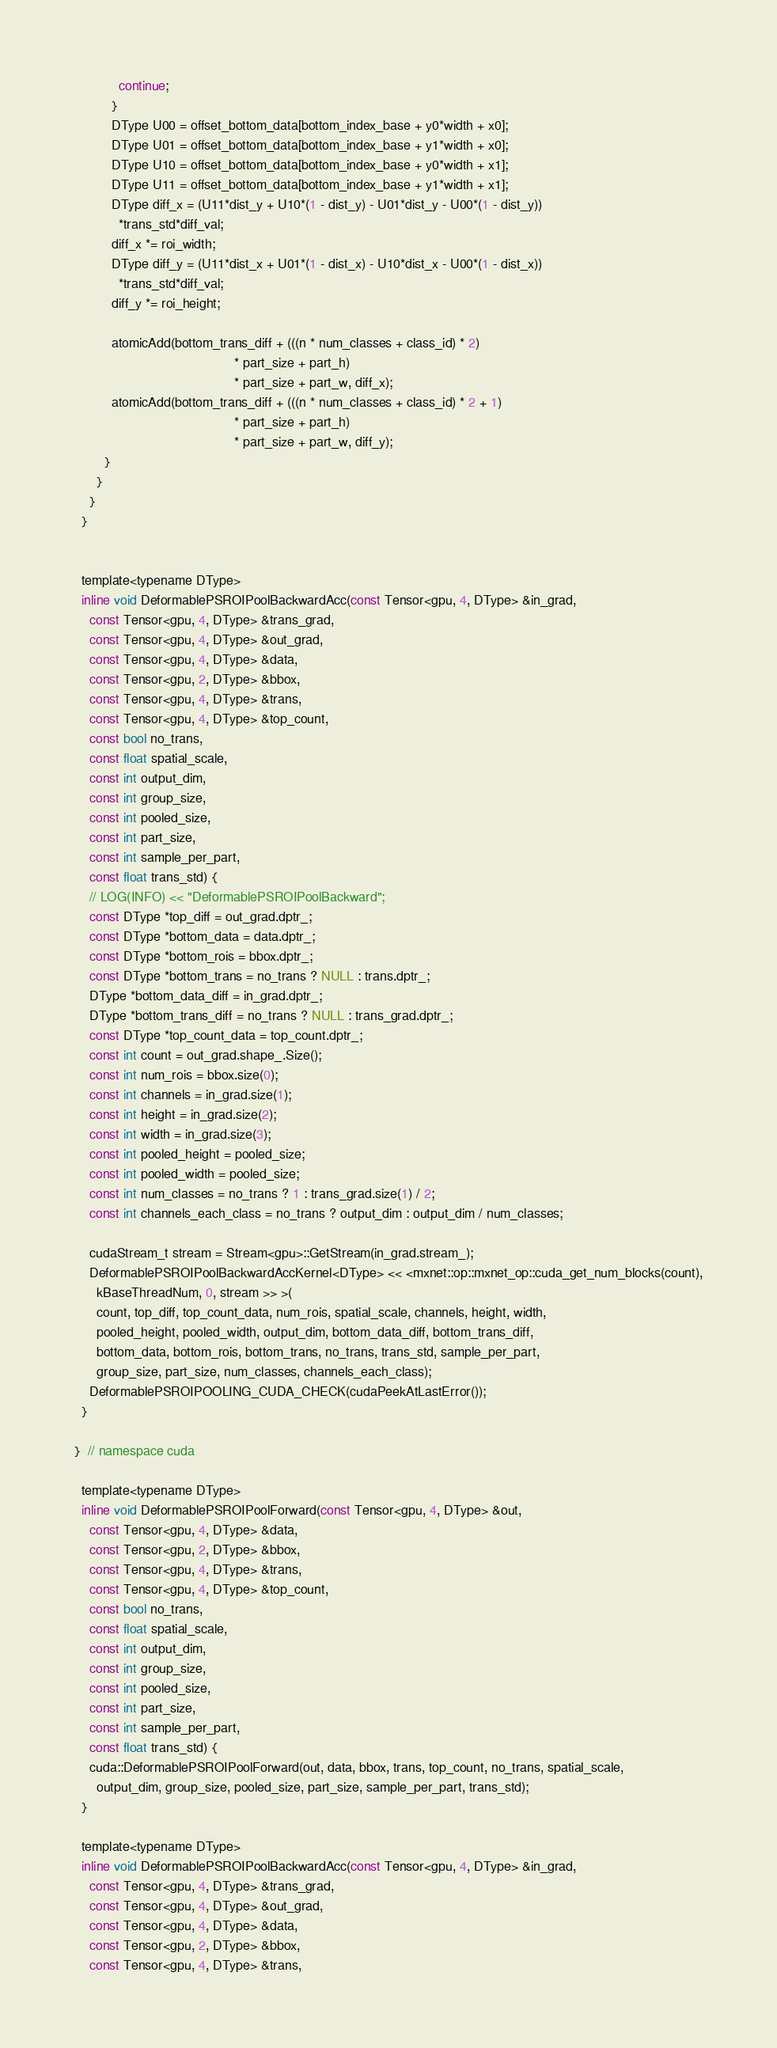Convert code to text. <code><loc_0><loc_0><loc_500><loc_500><_Cuda_>            continue;
          }
          DType U00 = offset_bottom_data[bottom_index_base + y0*width + x0];
          DType U01 = offset_bottom_data[bottom_index_base + y1*width + x0];
          DType U10 = offset_bottom_data[bottom_index_base + y0*width + x1];
          DType U11 = offset_bottom_data[bottom_index_base + y1*width + x1];
          DType diff_x = (U11*dist_y + U10*(1 - dist_y) - U01*dist_y - U00*(1 - dist_y))
            *trans_std*diff_val;
          diff_x *= roi_width;
          DType diff_y = (U11*dist_x + U01*(1 - dist_x) - U10*dist_x - U00*(1 - dist_x))
            *trans_std*diff_val;
          diff_y *= roi_height;

          atomicAdd(bottom_trans_diff + (((n * num_classes + class_id) * 2)
                                           * part_size + part_h)
                                           * part_size + part_w, diff_x);
          atomicAdd(bottom_trans_diff + (((n * num_classes + class_id) * 2 + 1)
                                           * part_size + part_h)
                                           * part_size + part_w, diff_y);
        }
      }
    }
  }


  template<typename DType>
  inline void DeformablePSROIPoolBackwardAcc(const Tensor<gpu, 4, DType> &in_grad,
    const Tensor<gpu, 4, DType> &trans_grad,
    const Tensor<gpu, 4, DType> &out_grad,
    const Tensor<gpu, 4, DType> &data,
    const Tensor<gpu, 2, DType> &bbox,
    const Tensor<gpu, 4, DType> &trans,
    const Tensor<gpu, 4, DType> &top_count,
    const bool no_trans,
    const float spatial_scale,
    const int output_dim,
    const int group_size,
    const int pooled_size,
    const int part_size,
    const int sample_per_part,
    const float trans_std) {
    // LOG(INFO) << "DeformablePSROIPoolBackward";
    const DType *top_diff = out_grad.dptr_;
    const DType *bottom_data = data.dptr_;
    const DType *bottom_rois = bbox.dptr_;
    const DType *bottom_trans = no_trans ? NULL : trans.dptr_;
    DType *bottom_data_diff = in_grad.dptr_;
    DType *bottom_trans_diff = no_trans ? NULL : trans_grad.dptr_;
    const DType *top_count_data = top_count.dptr_;
    const int count = out_grad.shape_.Size();
    const int num_rois = bbox.size(0);
    const int channels = in_grad.size(1);
    const int height = in_grad.size(2);
    const int width = in_grad.size(3);
    const int pooled_height = pooled_size;
    const int pooled_width = pooled_size;
    const int num_classes = no_trans ? 1 : trans_grad.size(1) / 2;
    const int channels_each_class = no_trans ? output_dim : output_dim / num_classes;

    cudaStream_t stream = Stream<gpu>::GetStream(in_grad.stream_);
    DeformablePSROIPoolBackwardAccKernel<DType> << <mxnet::op::mxnet_op::cuda_get_num_blocks(count),
      kBaseThreadNum, 0, stream >> >(
      count, top_diff, top_count_data, num_rois, spatial_scale, channels, height, width,
      pooled_height, pooled_width, output_dim, bottom_data_diff, bottom_trans_diff,
      bottom_data, bottom_rois, bottom_trans, no_trans, trans_std, sample_per_part,
      group_size, part_size, num_classes, channels_each_class);
    DeformablePSROIPOOLING_CUDA_CHECK(cudaPeekAtLastError());
  }

}  // namespace cuda

  template<typename DType>
  inline void DeformablePSROIPoolForward(const Tensor<gpu, 4, DType> &out,
    const Tensor<gpu, 4, DType> &data,
    const Tensor<gpu, 2, DType> &bbox,
    const Tensor<gpu, 4, DType> &trans,
    const Tensor<gpu, 4, DType> &top_count,
    const bool no_trans,
    const float spatial_scale,
    const int output_dim,
    const int group_size,
    const int pooled_size,
    const int part_size,
    const int sample_per_part,
    const float trans_std) {
    cuda::DeformablePSROIPoolForward(out, data, bbox, trans, top_count, no_trans, spatial_scale,
      output_dim, group_size, pooled_size, part_size, sample_per_part, trans_std);
  }

  template<typename DType>
  inline void DeformablePSROIPoolBackwardAcc(const Tensor<gpu, 4, DType> &in_grad,
    const Tensor<gpu, 4, DType> &trans_grad,
    const Tensor<gpu, 4, DType> &out_grad,
    const Tensor<gpu, 4, DType> &data,
    const Tensor<gpu, 2, DType> &bbox,
    const Tensor<gpu, 4, DType> &trans,</code> 